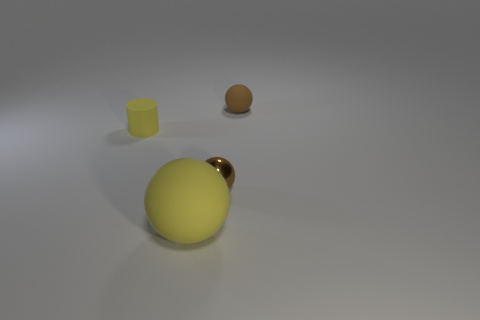Subtract all brown cylinders. How many brown spheres are left? 2 Subtract all small brown balls. How many balls are left? 1 Add 3 small brown things. How many objects exist? 7 Subtract 1 balls. How many balls are left? 2 Subtract all cyan balls. Subtract all yellow cylinders. How many balls are left? 3 Subtract all balls. How many objects are left? 1 Subtract 0 purple cubes. How many objects are left? 4 Subtract all big yellow rubber balls. Subtract all large yellow objects. How many objects are left? 2 Add 1 metal balls. How many metal balls are left? 2 Add 4 matte cylinders. How many matte cylinders exist? 5 